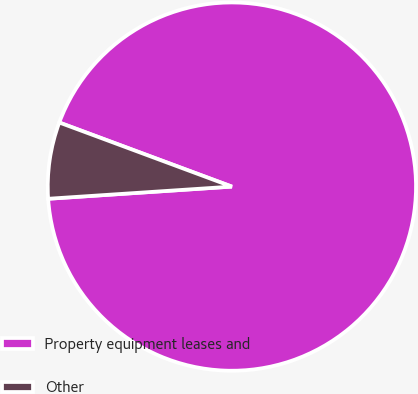<chart> <loc_0><loc_0><loc_500><loc_500><pie_chart><fcel>Property equipment leases and<fcel>Other<nl><fcel>93.29%<fcel>6.71%<nl></chart> 